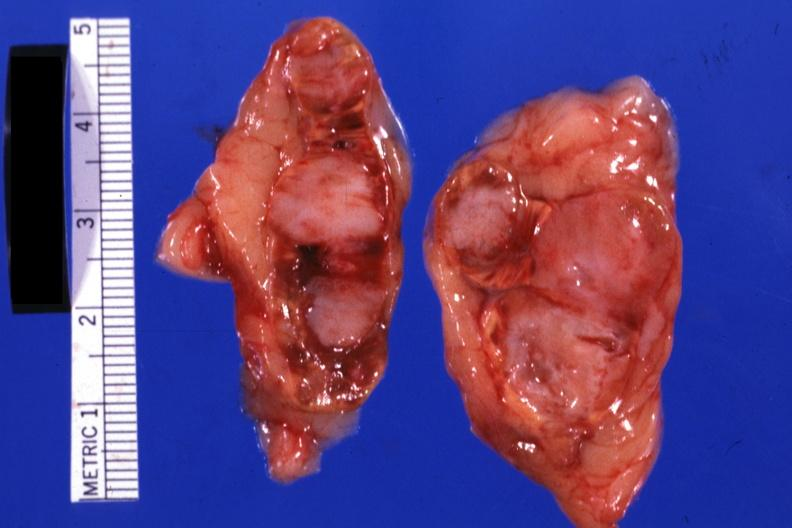what is present?
Answer the question using a single word or phrase. Adrenal 